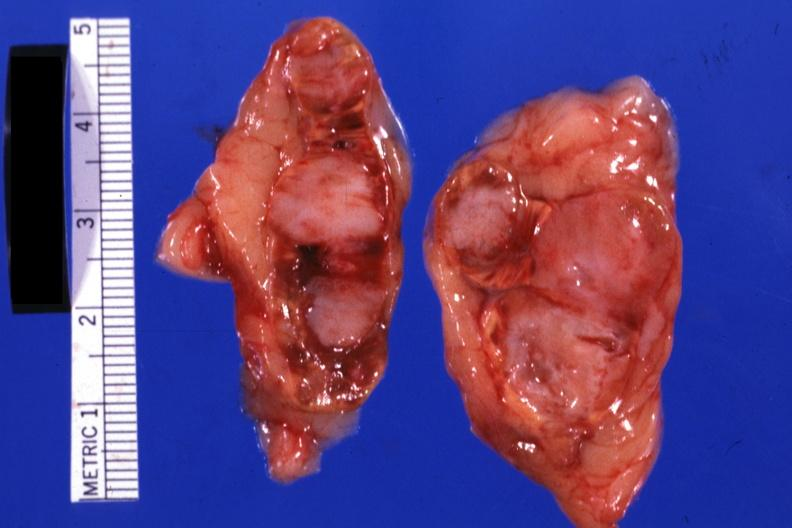what is present?
Answer the question using a single word or phrase. Adrenal 